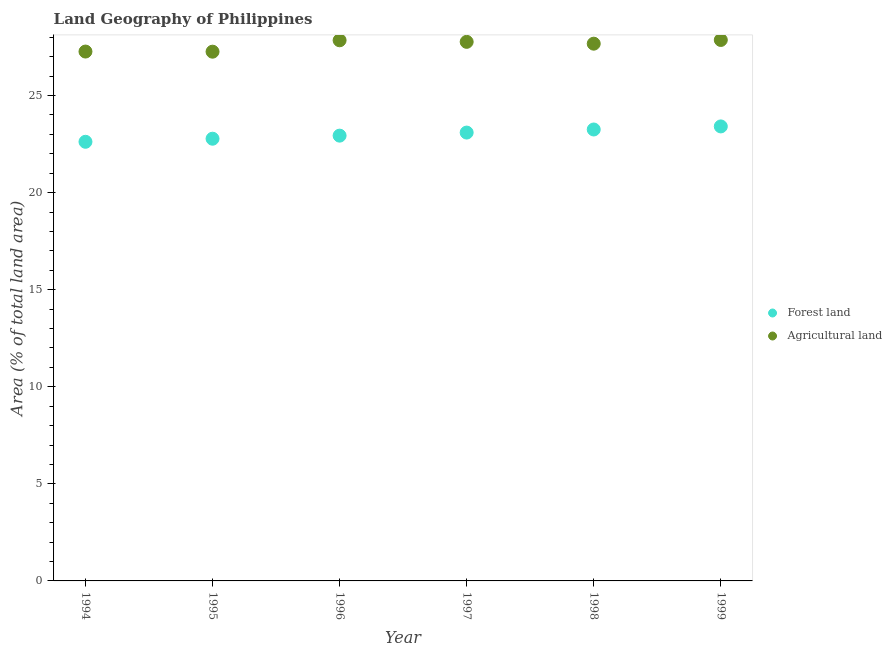How many different coloured dotlines are there?
Keep it short and to the point. 2. Is the number of dotlines equal to the number of legend labels?
Keep it short and to the point. Yes. What is the percentage of land area under agriculture in 1998?
Provide a short and direct response. 27.67. Across all years, what is the maximum percentage of land area under agriculture?
Keep it short and to the point. 27.86. Across all years, what is the minimum percentage of land area under agriculture?
Your answer should be very brief. 27.26. In which year was the percentage of land area under forests maximum?
Give a very brief answer. 1999. What is the total percentage of land area under forests in the graph?
Make the answer very short. 138.08. What is the difference between the percentage of land area under forests in 1998 and that in 1999?
Offer a terse response. -0.16. What is the difference between the percentage of land area under forests in 1996 and the percentage of land area under agriculture in 1995?
Offer a terse response. -4.32. What is the average percentage of land area under forests per year?
Provide a short and direct response. 23.01. In the year 1999, what is the difference between the percentage of land area under forests and percentage of land area under agriculture?
Your answer should be compact. -4.45. What is the ratio of the percentage of land area under agriculture in 1995 to that in 1996?
Provide a succinct answer. 0.98. What is the difference between the highest and the second highest percentage of land area under forests?
Offer a terse response. 0.16. What is the difference between the highest and the lowest percentage of land area under forests?
Provide a succinct answer. 0.79. Does the percentage of land area under agriculture monotonically increase over the years?
Your response must be concise. No. Is the percentage of land area under agriculture strictly greater than the percentage of land area under forests over the years?
Offer a terse response. Yes. Is the percentage of land area under forests strictly less than the percentage of land area under agriculture over the years?
Your answer should be very brief. Yes. How many dotlines are there?
Your response must be concise. 2. Does the graph contain grids?
Provide a succinct answer. No. What is the title of the graph?
Provide a short and direct response. Land Geography of Philippines. Does "Total Population" appear as one of the legend labels in the graph?
Keep it short and to the point. No. What is the label or title of the X-axis?
Offer a terse response. Year. What is the label or title of the Y-axis?
Provide a succinct answer. Area (% of total land area). What is the Area (% of total land area) of Forest land in 1994?
Your response must be concise. 22.62. What is the Area (% of total land area) of Agricultural land in 1994?
Your answer should be compact. 27.26. What is the Area (% of total land area) of Forest land in 1995?
Your answer should be compact. 22.78. What is the Area (% of total land area) of Agricultural land in 1995?
Offer a very short reply. 27.26. What is the Area (% of total land area) of Forest land in 1996?
Keep it short and to the point. 22.93. What is the Area (% of total land area) of Agricultural land in 1996?
Offer a terse response. 27.84. What is the Area (% of total land area) in Forest land in 1997?
Ensure brevity in your answer.  23.09. What is the Area (% of total land area) in Agricultural land in 1997?
Keep it short and to the point. 27.76. What is the Area (% of total land area) in Forest land in 1998?
Offer a very short reply. 23.25. What is the Area (% of total land area) of Agricultural land in 1998?
Keep it short and to the point. 27.67. What is the Area (% of total land area) in Forest land in 1999?
Offer a terse response. 23.41. What is the Area (% of total land area) in Agricultural land in 1999?
Your answer should be very brief. 27.86. Across all years, what is the maximum Area (% of total land area) in Forest land?
Offer a very short reply. 23.41. Across all years, what is the maximum Area (% of total land area) of Agricultural land?
Your answer should be very brief. 27.86. Across all years, what is the minimum Area (% of total land area) of Forest land?
Your answer should be very brief. 22.62. Across all years, what is the minimum Area (% of total land area) of Agricultural land?
Your answer should be very brief. 27.26. What is the total Area (% of total land area) in Forest land in the graph?
Your answer should be compact. 138.08. What is the total Area (% of total land area) of Agricultural land in the graph?
Give a very brief answer. 165.66. What is the difference between the Area (% of total land area) in Forest land in 1994 and that in 1995?
Provide a short and direct response. -0.16. What is the difference between the Area (% of total land area) of Agricultural land in 1994 and that in 1995?
Provide a succinct answer. 0.01. What is the difference between the Area (% of total land area) in Forest land in 1994 and that in 1996?
Your answer should be very brief. -0.32. What is the difference between the Area (% of total land area) of Agricultural land in 1994 and that in 1996?
Keep it short and to the point. -0.58. What is the difference between the Area (% of total land area) in Forest land in 1994 and that in 1997?
Provide a succinct answer. -0.47. What is the difference between the Area (% of total land area) in Agricultural land in 1994 and that in 1997?
Your answer should be very brief. -0.5. What is the difference between the Area (% of total land area) of Forest land in 1994 and that in 1998?
Offer a terse response. -0.63. What is the difference between the Area (% of total land area) in Agricultural land in 1994 and that in 1998?
Your answer should be compact. -0.41. What is the difference between the Area (% of total land area) in Forest land in 1994 and that in 1999?
Offer a terse response. -0.79. What is the difference between the Area (% of total land area) of Agricultural land in 1994 and that in 1999?
Keep it short and to the point. -0.6. What is the difference between the Area (% of total land area) of Forest land in 1995 and that in 1996?
Offer a very short reply. -0.16. What is the difference between the Area (% of total land area) in Agricultural land in 1995 and that in 1996?
Offer a terse response. -0.59. What is the difference between the Area (% of total land area) in Forest land in 1995 and that in 1997?
Keep it short and to the point. -0.32. What is the difference between the Area (% of total land area) in Agricultural land in 1995 and that in 1997?
Offer a very short reply. -0.51. What is the difference between the Area (% of total land area) in Forest land in 1995 and that in 1998?
Your answer should be very brief. -0.47. What is the difference between the Area (% of total land area) of Agricultural land in 1995 and that in 1998?
Offer a terse response. -0.41. What is the difference between the Area (% of total land area) of Forest land in 1995 and that in 1999?
Ensure brevity in your answer.  -0.63. What is the difference between the Area (% of total land area) of Agricultural land in 1995 and that in 1999?
Make the answer very short. -0.6. What is the difference between the Area (% of total land area) in Forest land in 1996 and that in 1997?
Make the answer very short. -0.16. What is the difference between the Area (% of total land area) in Agricultural land in 1996 and that in 1997?
Ensure brevity in your answer.  0.08. What is the difference between the Area (% of total land area) in Forest land in 1996 and that in 1998?
Offer a very short reply. -0.32. What is the difference between the Area (% of total land area) in Agricultural land in 1996 and that in 1998?
Ensure brevity in your answer.  0.17. What is the difference between the Area (% of total land area) in Forest land in 1996 and that in 1999?
Provide a succinct answer. -0.47. What is the difference between the Area (% of total land area) in Agricultural land in 1996 and that in 1999?
Offer a terse response. -0.02. What is the difference between the Area (% of total land area) of Forest land in 1997 and that in 1998?
Ensure brevity in your answer.  -0.16. What is the difference between the Area (% of total land area) of Agricultural land in 1997 and that in 1998?
Your answer should be very brief. 0.09. What is the difference between the Area (% of total land area) in Forest land in 1997 and that in 1999?
Provide a short and direct response. -0.32. What is the difference between the Area (% of total land area) in Agricultural land in 1997 and that in 1999?
Your answer should be very brief. -0.1. What is the difference between the Area (% of total land area) in Forest land in 1998 and that in 1999?
Give a very brief answer. -0.16. What is the difference between the Area (% of total land area) in Agricultural land in 1998 and that in 1999?
Your response must be concise. -0.19. What is the difference between the Area (% of total land area) in Forest land in 1994 and the Area (% of total land area) in Agricultural land in 1995?
Offer a very short reply. -4.64. What is the difference between the Area (% of total land area) of Forest land in 1994 and the Area (% of total land area) of Agricultural land in 1996?
Your answer should be compact. -5.23. What is the difference between the Area (% of total land area) of Forest land in 1994 and the Area (% of total land area) of Agricultural land in 1997?
Give a very brief answer. -5.15. What is the difference between the Area (% of total land area) in Forest land in 1994 and the Area (% of total land area) in Agricultural land in 1998?
Your answer should be very brief. -5.05. What is the difference between the Area (% of total land area) of Forest land in 1994 and the Area (% of total land area) of Agricultural land in 1999?
Offer a very short reply. -5.24. What is the difference between the Area (% of total land area) of Forest land in 1995 and the Area (% of total land area) of Agricultural land in 1996?
Give a very brief answer. -5.07. What is the difference between the Area (% of total land area) of Forest land in 1995 and the Area (% of total land area) of Agricultural land in 1997?
Keep it short and to the point. -4.99. What is the difference between the Area (% of total land area) of Forest land in 1995 and the Area (% of total land area) of Agricultural land in 1998?
Offer a terse response. -4.89. What is the difference between the Area (% of total land area) in Forest land in 1995 and the Area (% of total land area) in Agricultural land in 1999?
Make the answer very short. -5.09. What is the difference between the Area (% of total land area) in Forest land in 1996 and the Area (% of total land area) in Agricultural land in 1997?
Keep it short and to the point. -4.83. What is the difference between the Area (% of total land area) of Forest land in 1996 and the Area (% of total land area) of Agricultural land in 1998?
Ensure brevity in your answer.  -4.74. What is the difference between the Area (% of total land area) of Forest land in 1996 and the Area (% of total land area) of Agricultural land in 1999?
Your answer should be compact. -4.93. What is the difference between the Area (% of total land area) of Forest land in 1997 and the Area (% of total land area) of Agricultural land in 1998?
Ensure brevity in your answer.  -4.58. What is the difference between the Area (% of total land area) of Forest land in 1997 and the Area (% of total land area) of Agricultural land in 1999?
Provide a succinct answer. -4.77. What is the difference between the Area (% of total land area) of Forest land in 1998 and the Area (% of total land area) of Agricultural land in 1999?
Ensure brevity in your answer.  -4.61. What is the average Area (% of total land area) in Forest land per year?
Offer a terse response. 23.01. What is the average Area (% of total land area) in Agricultural land per year?
Provide a succinct answer. 27.61. In the year 1994, what is the difference between the Area (% of total land area) in Forest land and Area (% of total land area) in Agricultural land?
Your response must be concise. -4.65. In the year 1995, what is the difference between the Area (% of total land area) of Forest land and Area (% of total land area) of Agricultural land?
Ensure brevity in your answer.  -4.48. In the year 1996, what is the difference between the Area (% of total land area) in Forest land and Area (% of total land area) in Agricultural land?
Provide a succinct answer. -4.91. In the year 1997, what is the difference between the Area (% of total land area) in Forest land and Area (% of total land area) in Agricultural land?
Your answer should be very brief. -4.67. In the year 1998, what is the difference between the Area (% of total land area) in Forest land and Area (% of total land area) in Agricultural land?
Ensure brevity in your answer.  -4.42. In the year 1999, what is the difference between the Area (% of total land area) in Forest land and Area (% of total land area) in Agricultural land?
Give a very brief answer. -4.45. What is the ratio of the Area (% of total land area) of Agricultural land in 1994 to that in 1995?
Offer a very short reply. 1. What is the ratio of the Area (% of total land area) in Forest land in 1994 to that in 1996?
Your answer should be compact. 0.99. What is the ratio of the Area (% of total land area) of Agricultural land in 1994 to that in 1996?
Offer a terse response. 0.98. What is the ratio of the Area (% of total land area) in Forest land in 1994 to that in 1997?
Provide a succinct answer. 0.98. What is the ratio of the Area (% of total land area) of Forest land in 1994 to that in 1998?
Ensure brevity in your answer.  0.97. What is the ratio of the Area (% of total land area) of Forest land in 1994 to that in 1999?
Make the answer very short. 0.97. What is the ratio of the Area (% of total land area) of Agricultural land in 1994 to that in 1999?
Provide a succinct answer. 0.98. What is the ratio of the Area (% of total land area) in Forest land in 1995 to that in 1996?
Give a very brief answer. 0.99. What is the ratio of the Area (% of total land area) in Agricultural land in 1995 to that in 1996?
Your answer should be compact. 0.98. What is the ratio of the Area (% of total land area) in Forest land in 1995 to that in 1997?
Keep it short and to the point. 0.99. What is the ratio of the Area (% of total land area) in Agricultural land in 1995 to that in 1997?
Offer a terse response. 0.98. What is the ratio of the Area (% of total land area) of Forest land in 1995 to that in 1998?
Provide a short and direct response. 0.98. What is the ratio of the Area (% of total land area) of Agricultural land in 1995 to that in 1998?
Make the answer very short. 0.99. What is the ratio of the Area (% of total land area) of Forest land in 1995 to that in 1999?
Provide a short and direct response. 0.97. What is the ratio of the Area (% of total land area) in Agricultural land in 1995 to that in 1999?
Give a very brief answer. 0.98. What is the ratio of the Area (% of total land area) in Forest land in 1996 to that in 1998?
Give a very brief answer. 0.99. What is the ratio of the Area (% of total land area) in Agricultural land in 1996 to that in 1998?
Make the answer very short. 1.01. What is the ratio of the Area (% of total land area) in Forest land in 1996 to that in 1999?
Make the answer very short. 0.98. What is the ratio of the Area (% of total land area) in Agricultural land in 1996 to that in 1999?
Provide a short and direct response. 1. What is the ratio of the Area (% of total land area) of Forest land in 1997 to that in 1998?
Provide a short and direct response. 0.99. What is the ratio of the Area (% of total land area) in Agricultural land in 1997 to that in 1998?
Your answer should be very brief. 1. What is the ratio of the Area (% of total land area) of Forest land in 1997 to that in 1999?
Give a very brief answer. 0.99. What is the ratio of the Area (% of total land area) in Agricultural land in 1998 to that in 1999?
Offer a very short reply. 0.99. What is the difference between the highest and the second highest Area (% of total land area) of Forest land?
Your answer should be very brief. 0.16. What is the difference between the highest and the second highest Area (% of total land area) of Agricultural land?
Your response must be concise. 0.02. What is the difference between the highest and the lowest Area (% of total land area) of Forest land?
Make the answer very short. 0.79. What is the difference between the highest and the lowest Area (% of total land area) in Agricultural land?
Provide a short and direct response. 0.6. 